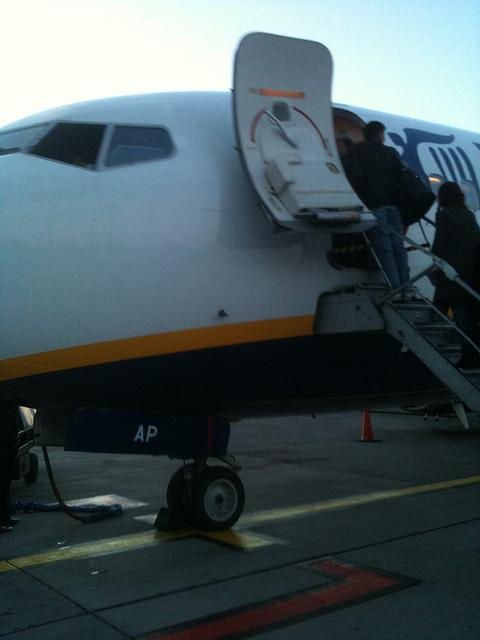What popular news agency as the same Acronym as the letters near the bottom of the plane? Please explain your reasoning. associated press. The letters displayed is ap which is the initials for associated press which is a news agency. 